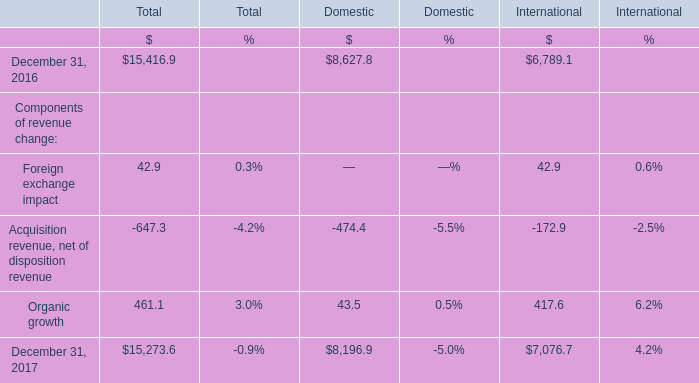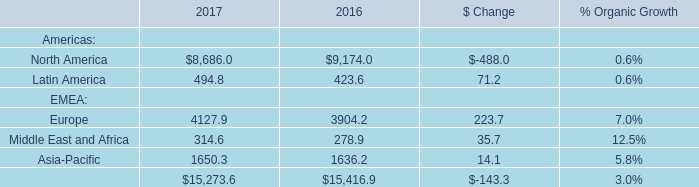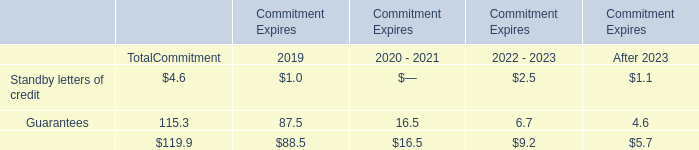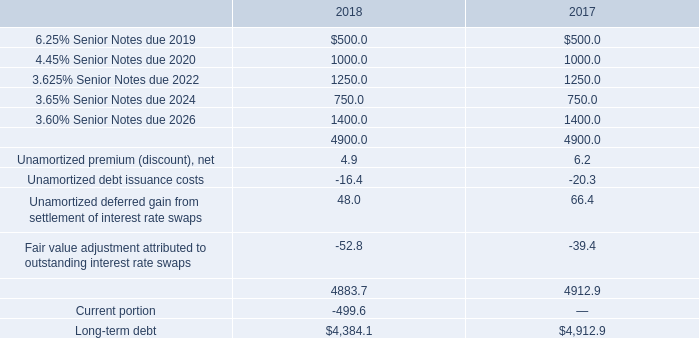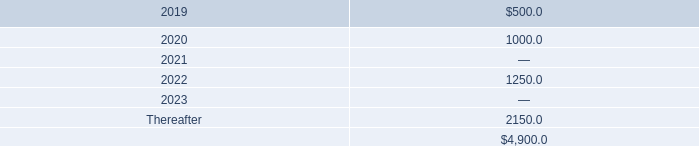What is the sum of Organic growth in the range of 5000 and 1000 in 2016? ( 
Computations: (417.6 + 43.5)
Answer: 461.1. 